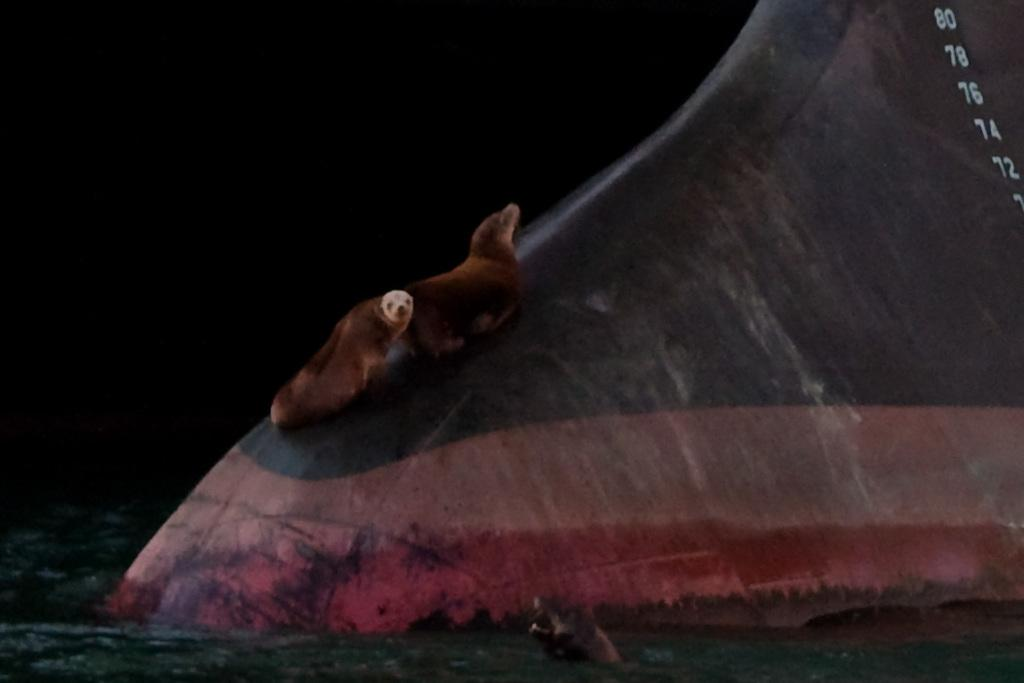What is the main subject of the image? There are animals on a structure in the image. What can be observed about the background of the image? The background of the image is dark. Are there any animals in a different environment within the image? Yes, there is an animal in the water at the bottom of the image. What type of wool is being used by the animals in the image? There is no wool present in the image, and the animals are not using any wool. 